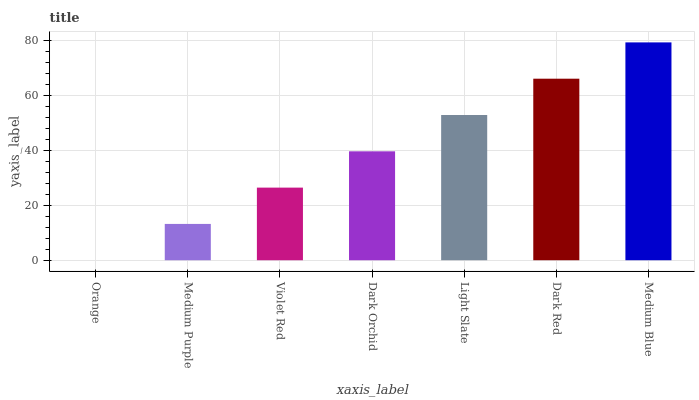Is Orange the minimum?
Answer yes or no. Yes. Is Medium Blue the maximum?
Answer yes or no. Yes. Is Medium Purple the minimum?
Answer yes or no. No. Is Medium Purple the maximum?
Answer yes or no. No. Is Medium Purple greater than Orange?
Answer yes or no. Yes. Is Orange less than Medium Purple?
Answer yes or no. Yes. Is Orange greater than Medium Purple?
Answer yes or no. No. Is Medium Purple less than Orange?
Answer yes or no. No. Is Dark Orchid the high median?
Answer yes or no. Yes. Is Dark Orchid the low median?
Answer yes or no. Yes. Is Orange the high median?
Answer yes or no. No. Is Medium Purple the low median?
Answer yes or no. No. 